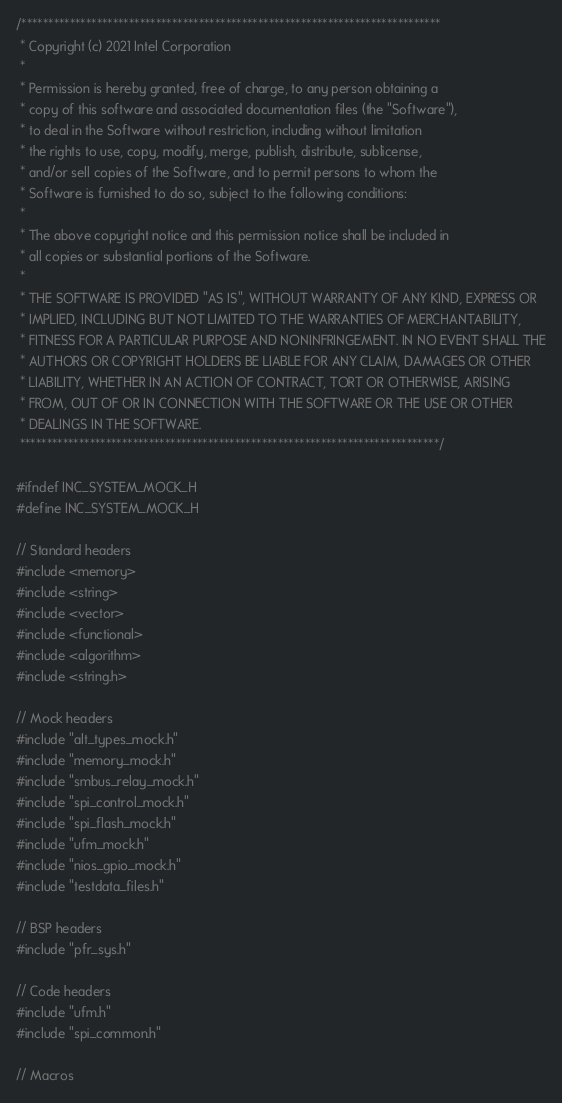Convert code to text. <code><loc_0><loc_0><loc_500><loc_500><_C_>/******************************************************************************
 * Copyright (c) 2021 Intel Corporation
 *
 * Permission is hereby granted, free of charge, to any person obtaining a
 * copy of this software and associated documentation files (the "Software"),
 * to deal in the Software without restriction, including without limitation
 * the rights to use, copy, modify, merge, publish, distribute, sublicense,
 * and/or sell copies of the Software, and to permit persons to whom the
 * Software is furnished to do so, subject to the following conditions:
 *
 * The above copyright notice and this permission notice shall be included in
 * all copies or substantial portions of the Software.
 *
 * THE SOFTWARE IS PROVIDED "AS IS", WITHOUT WARRANTY OF ANY KIND, EXPRESS OR
 * IMPLIED, INCLUDING BUT NOT LIMITED TO THE WARRANTIES OF MERCHANTABILITY,
 * FITNESS FOR A PARTICULAR PURPOSE AND NONINFRINGEMENT. IN NO EVENT SHALL THE
 * AUTHORS OR COPYRIGHT HOLDERS BE LIABLE FOR ANY CLAIM, DAMAGES OR OTHER
 * LIABILITY, WHETHER IN AN ACTION OF CONTRACT, TORT OR OTHERWISE, ARISING
 * FROM, OUT OF OR IN CONNECTION WITH THE SOFTWARE OR THE USE OR OTHER
 * DEALINGS IN THE SOFTWARE.
 ******************************************************************************/

#ifndef INC_SYSTEM_MOCK_H
#define INC_SYSTEM_MOCK_H

// Standard headers
#include <memory>
#include <string>
#include <vector>
#include <functional>
#include <algorithm>
#include <string.h>

// Mock headers
#include "alt_types_mock.h"
#include "memory_mock.h"
#include "smbus_relay_mock.h"
#include "spi_control_mock.h"
#include "spi_flash_mock.h"
#include "ufm_mock.h"
#include "nios_gpio_mock.h"
#include "testdata_files.h"

// BSP headers
#include "pfr_sys.h"

// Code headers
#include "ufm.h"
#include "spi_common.h"

// Macros</code> 